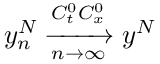Convert formula to latex. <formula><loc_0><loc_0><loc_500><loc_500>y _ { n } ^ { N } \xrightarrow [ n \rightarrow \infty ] { C _ { t } ^ { 0 } C _ { x } ^ { 0 } } y ^ { N }</formula> 